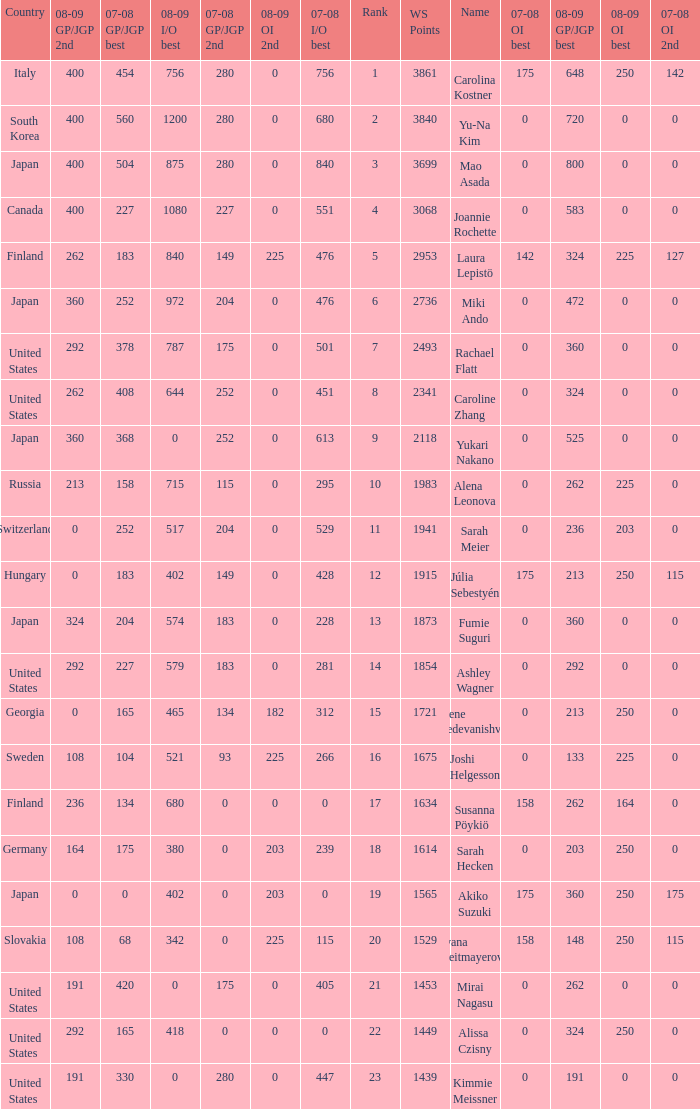08-09 gp/jgp 2nd is 213 and ws points will be what maximum 1983.0. 